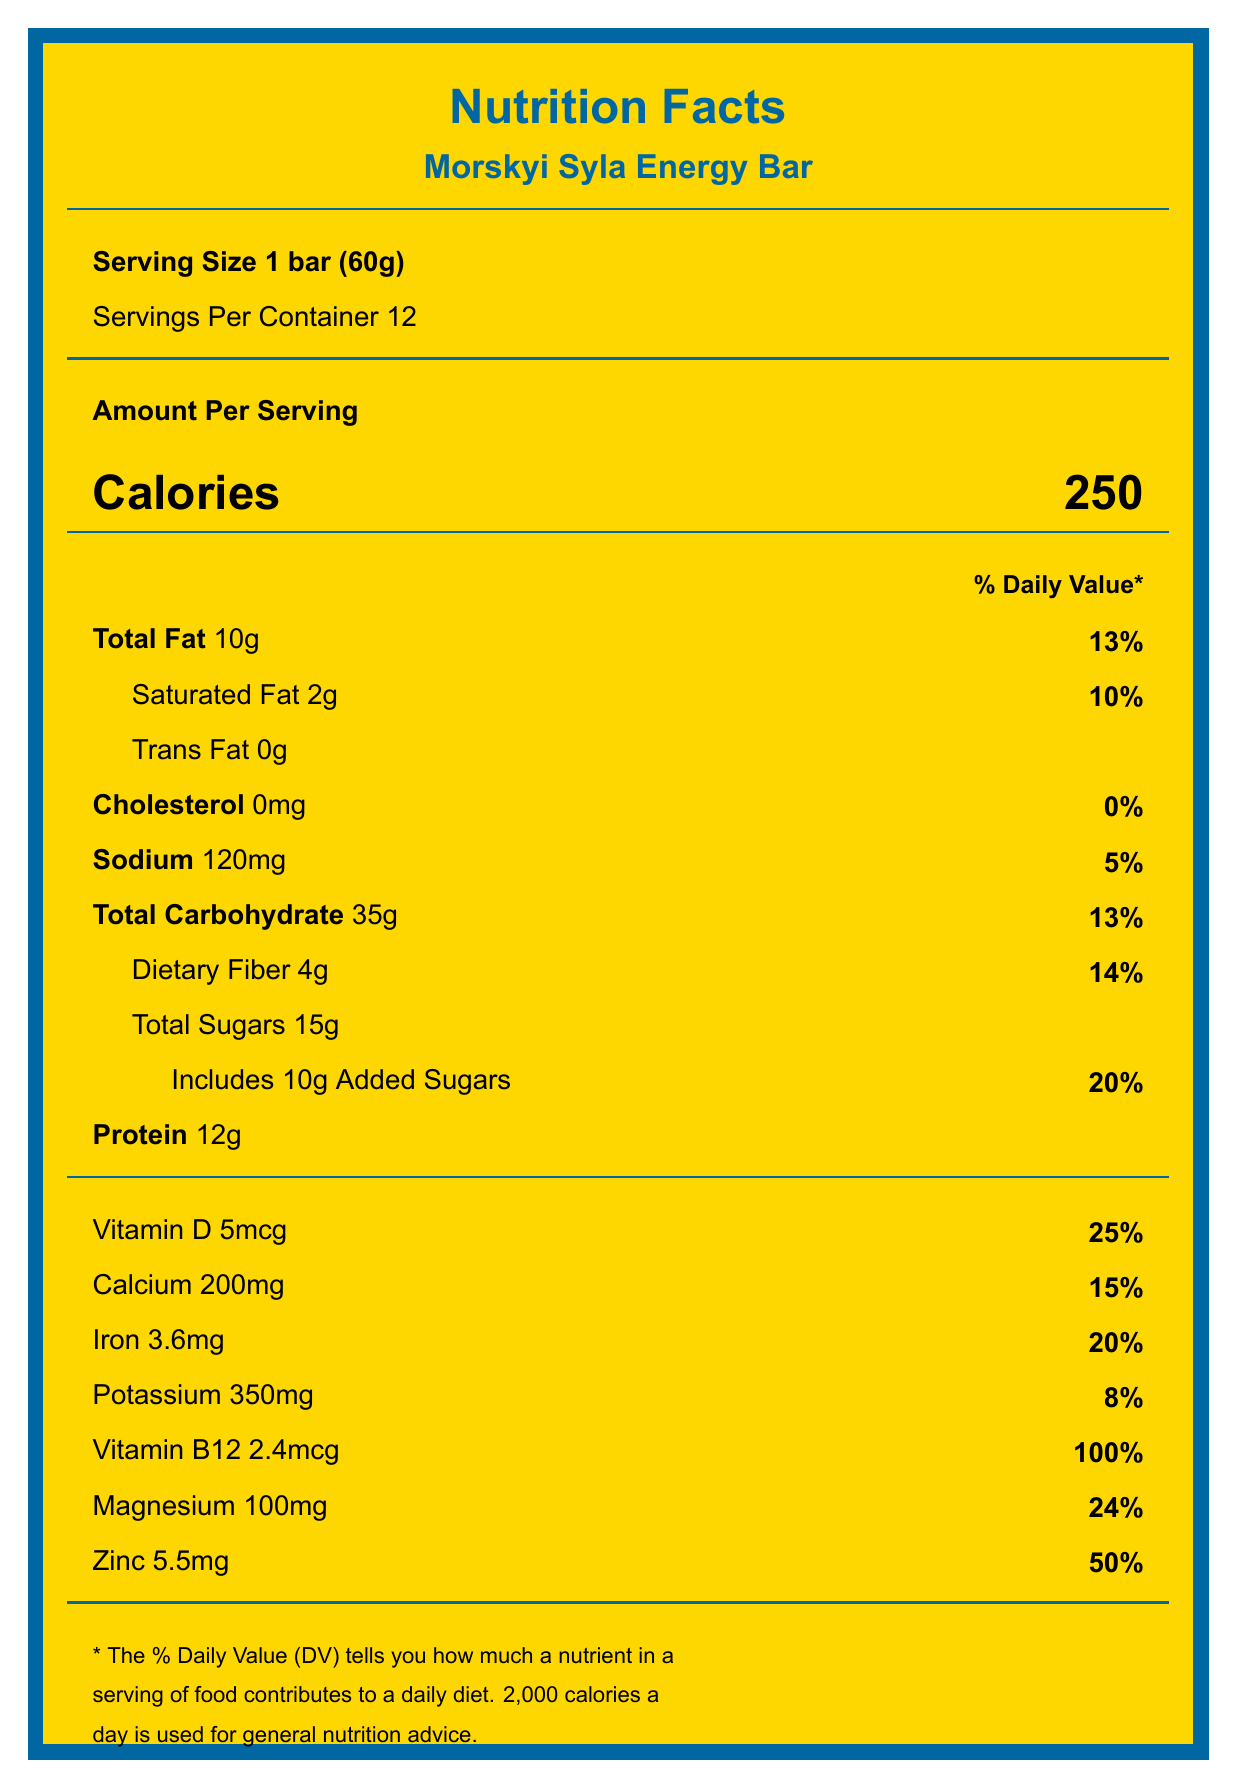How many calories are there per serving? The document states that there are 250 calories per serving.
Answer: 250 What is the serving size? The serving size is specified as 1 bar weighing 60 grams.
Answer: 1 bar (60g) How much dietary fiber does one serving contain? The label indicates that one serving contains 4 grams of dietary fiber.
Answer: 4g How much potassium does one serving provide? The document lists 350mg as the amount of potassium per serving.
Answer: 350mg What is the percentage of the daily value for added sugars in one serving? The label shows that added sugars contribute to 20% of the daily value in one serving.
Answer: 20% Which nutrient has the highest daily value percentage in one serving? A. Calcium B. Iron C. Vitamin B12 D. Magnesium Vitamin B12 is listed as providing 100% of the daily value per serving, the highest among the listed nutrients.
Answer: C. Vitamin B12 How much sodium is in one serving? A. 100mg B. 120mg C. 150mg D. 200mg The document states that each serving contains 120mg of sodium.
Answer: B. 120mg Does the energy bar contain any trans fat? The document indicates "0g" for trans fat.
Answer: No Summarize the key nutritional information for the Morskyi Syla Energy Bar. This summary captures the essential nutritional information, ingredients, and allergen warnings of the energy bar.
Answer: The Morskyi Syla Energy Bar provides 250 calories per serving (1 bar, 60g). It has 10g of total fat (13% DV), 2g of saturated fat (10% DV), 0g trans fat, 0mg cholesterol (0% DV), 120mg sodium (5% DV), 35g total carbohydrates (13% DV), 4g dietary fiber (14% DV), 15g total sugars, with 10g added sugars (20% DV), and 12g of protein. Significant vitamins and minerals include Vitamin D (25% DV), Calcium (15% DV), Iron (20% DV), Potassium (8% DV), Vitamin B12 (100% DV), Magnesium (24% DV), and Zinc (50% DV). The bar contains oats, honey, peanut butter, dried cherries, sunflower seeds, whey protein isolate, flaxseed, coconut oil, sea salt, and a vitamin and mineral blend. It has allergen warnings for peanuts and milk, and may contain traces of tree nuts and soy. What is the manufacturer's website? The document provides the manufacturer's website as "www.odesanutrition.ua".
Answer: www.odesanutrition.ua Are there any artificial preservatives in the Morskyi Syla Energy Bar? The label claims "No Artificial Preservatives".
Answer: No What is the address of the manufacturer? The manufacturer's address is provided as "7 Prymors'ka St., Odesa, 65026, Ukraine".
Answer: 7 Prymors'ka St., Odesa, 65026, Ukraine Can the exact percentage of Vitamin C in the energy bar be determined from the document? The document does not list Vitamin C, so its percentage cannot be determined.
Answer: Not enough information 